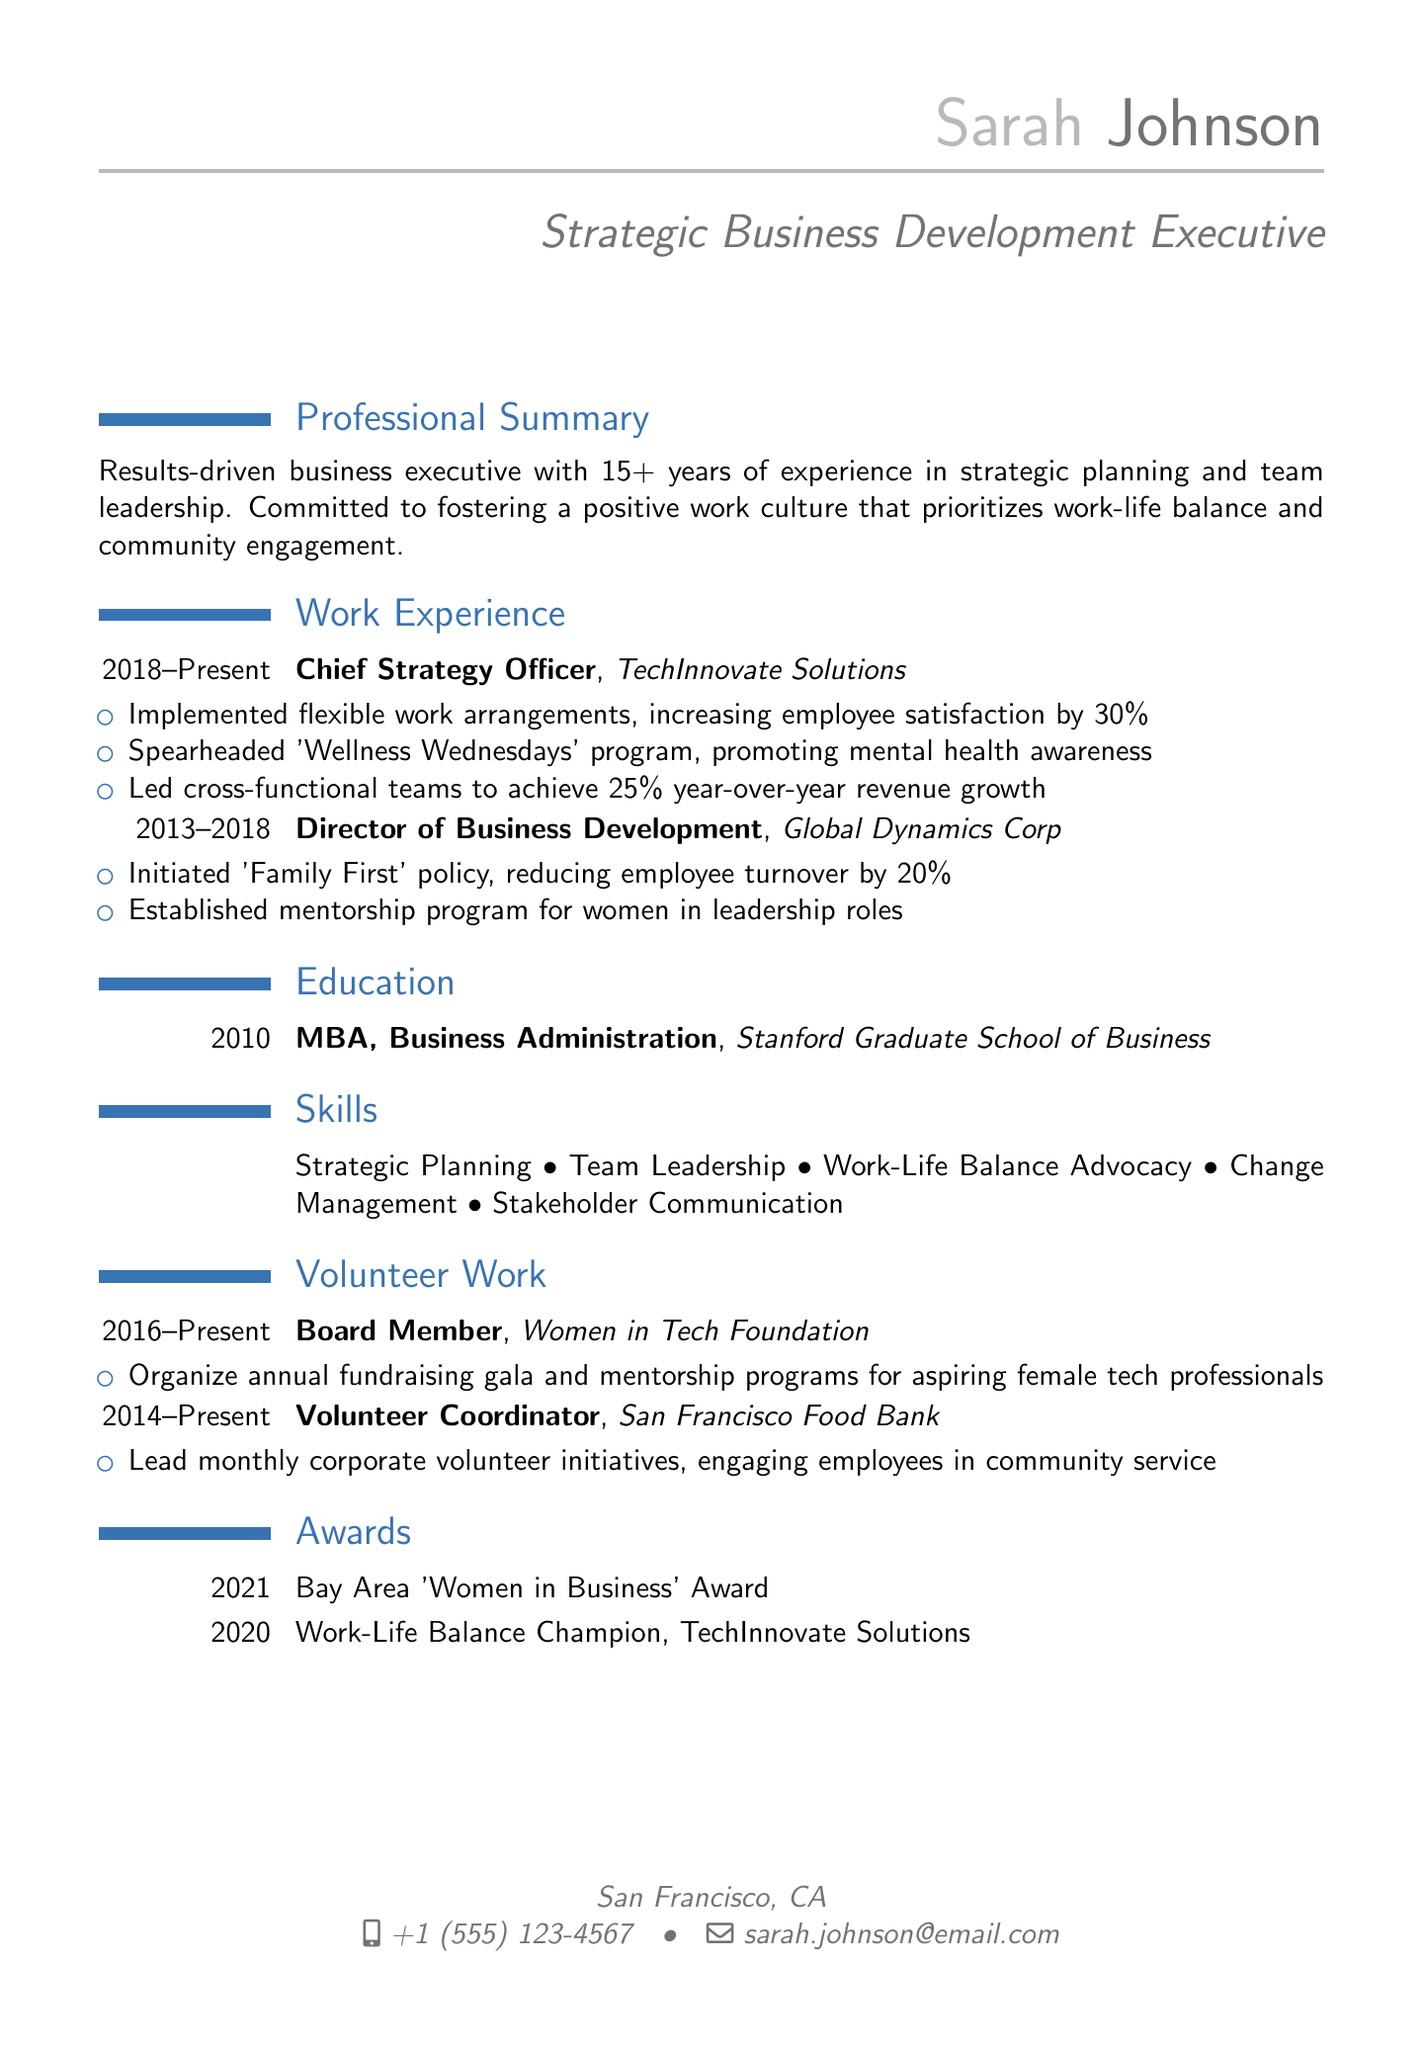what is the name of the person? The name listed at the top of the document is Sarah Johnson.
Answer: Sarah Johnson what is the current job title? The job title mentioned in the personal info section is Chief Strategy Officer.
Answer: Chief Strategy Officer how many years of experience does Sarah have? Sarah has been in her field for over 15 years as mentioned in the professional summary.
Answer: 15+ which company did Sarah work for from 2013 to 2018? The document states she worked at Global Dynamics Corp during that time.
Answer: Global Dynamics Corp what initiative increased employee satisfaction by 30%? The initiative that increased satisfaction is related to flexible work arrangements.
Answer: Flexible work arrangements what award did Sarah receive in 2021? The award mentioned is the Bay Area 'Women in Business' Award.
Answer: Bay Area 'Women in Business' Award what is the main focus of the Women in Tech Foundation? The focus of the organization is on organizing mentorship programs for aspiring female tech professionals.
Answer: Mentorship programs what policy did Sarah initiate at Global Dynamics Corp? The policy initiated is called 'Family First'.
Answer: Family First how many volunteer initiatives does Sarah lead per month at the San Francisco Food Bank? She leads monthly corporate volunteer initiatives as stated in the volunteer work section.
Answer: Monthly what skill related to work-life balance does Sarah advocate for? She advocates for work-life balance advocacy, as listed in her skills section.
Answer: Work-Life Balance Advocacy 